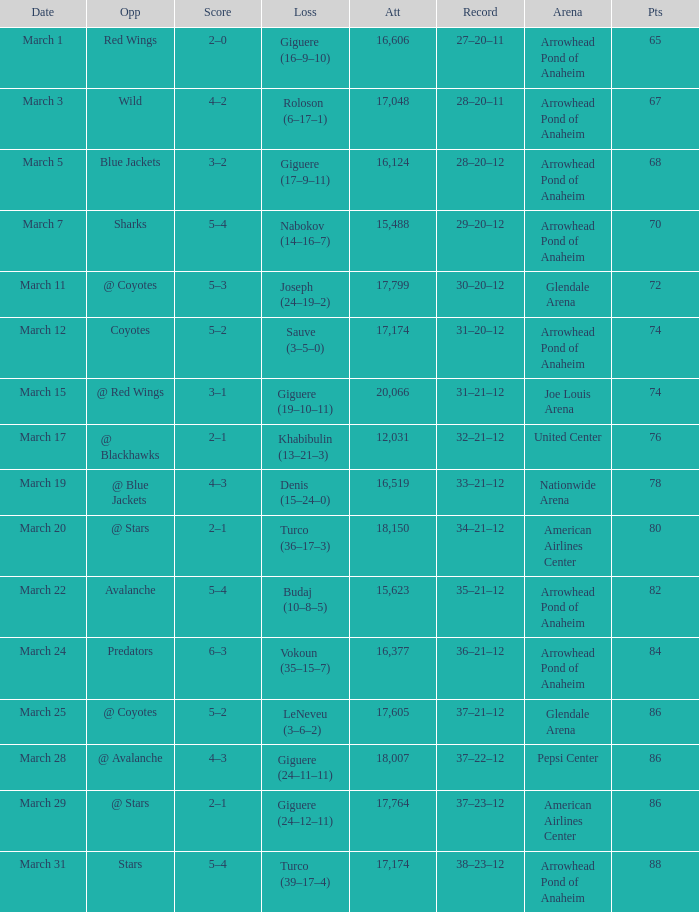What is the presence at joe louis arena? 20066.0. 